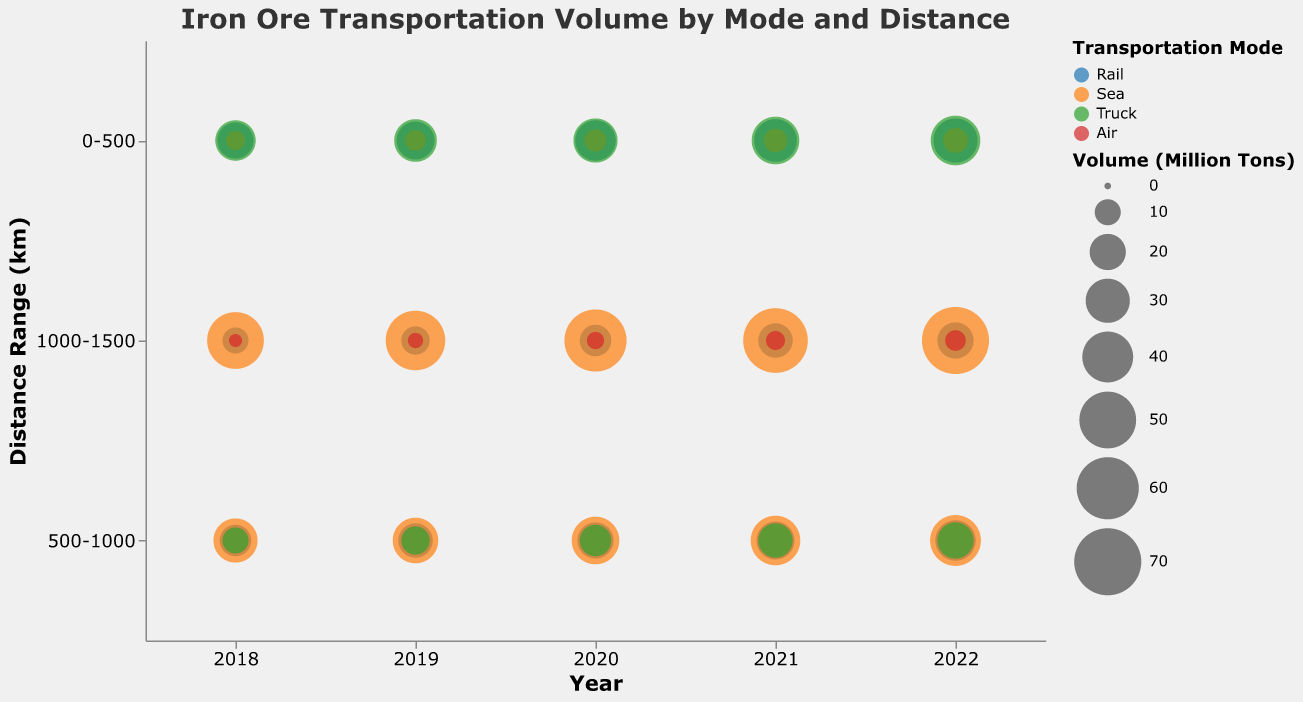What is the title of the figure? The title can be found at the top of the chart and reads "Iron Ore Transportation Volume by Mode and Distance."
Answer: Iron Ore Transportation Volume by Mode and Distance How many transportation modes are represented in the chart? There are four different colors indicating the transportation modes. The legend shows four modes: Rail, Sea, Truck, and Air.
Answer: 4 Which transportation mode transported the most volume for the distance range 1000-1500 km in 2022? Look at the size of the bubbles in the 2022 column for the distance range 1000-1500 km. The largest bubble there is for Sea.
Answer: Sea Compare the volume transported by Rail and Truck for the 0-500 km distance range in 2020. Which mode transported more volume? Find the bubbles for Rail and Truck in the 0-500 km distance range in 2020 and compare their sizes. Rail transported 25 million tons, and Truck transported 30 million tons, so Truck transported more.
Answer: Truck What is the total volume of iron ore transported by Sea in 2021? Sum the volumes for Sea in all distance ranges in 2021: 8 (0-500 km) + 38 (500-1000 km) + 65 (1000-1500 km) = 111 million tons.
Answer: 111 million tons Has the volume transported by Air in the distance range 1000-1500 km increased or decreased from 2018 to 2022? Look at the volume transported by Air in the 1000-1500 km range for 2018 and 2022. In 2018, it was 2 million tons, and in 2022, it was 6 million tons, indicating an increase.
Answer: Increased Between 2019 and 2020, did the volume transported by Truck in the 0-500 km distance range increase or decrease? Compare the volumes for Truck in the 0-500 km distance range for 2019 and 2020. In 2019, it was 28 million tons and in 2020, it was 30 million tons, so it increased.
Answer: Increased What is the volume difference between Rail and Sea for the distance range 500-1000 km in 2022? Look at the size of the bubbles for Rail and Sea in the 500-1000 km range in 2022. Rail transported 25 million tons and Sea transported 40 million tons. The difference is 40 - 25 = 15 million tons.
Answer: 15 million tons Which year had the highest total volume transported by all modes in the 0-500 km distance range? Sum the volumes for all transportation modes in the 0-500 km distance range for each year. The totals are: 
2018: Rail (20) + Sea (5) + Truck (25) = 50 
2019: Rail (22) + Sea (6) + Truck (28) = 56 
2020: Rail (25) + Sea (7) + Truck (30) = 62 
2021: Rail (28) + Sea (8) + Truck (35) = 71 
2022: Rail (30) + Sea (9) + Truck (38) = 77 
The highest total is 77 in 2022.
Answer: 2022 